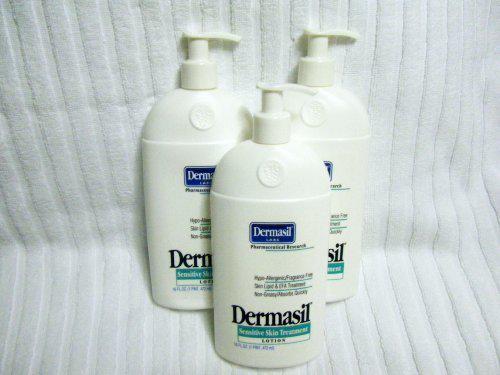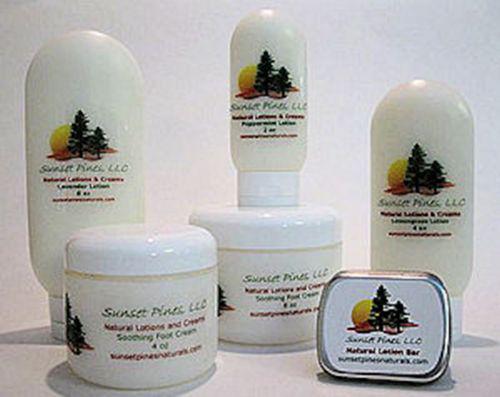The first image is the image on the left, the second image is the image on the right. For the images displayed, is the sentence "Some of the bottles in the right image have rounded tops." factually correct? Answer yes or no. Yes. The first image is the image on the left, the second image is the image on the right. Considering the images on both sides, is "The left image contains exactly three bottles, all of the same size and shape." valid? Answer yes or no. Yes. 